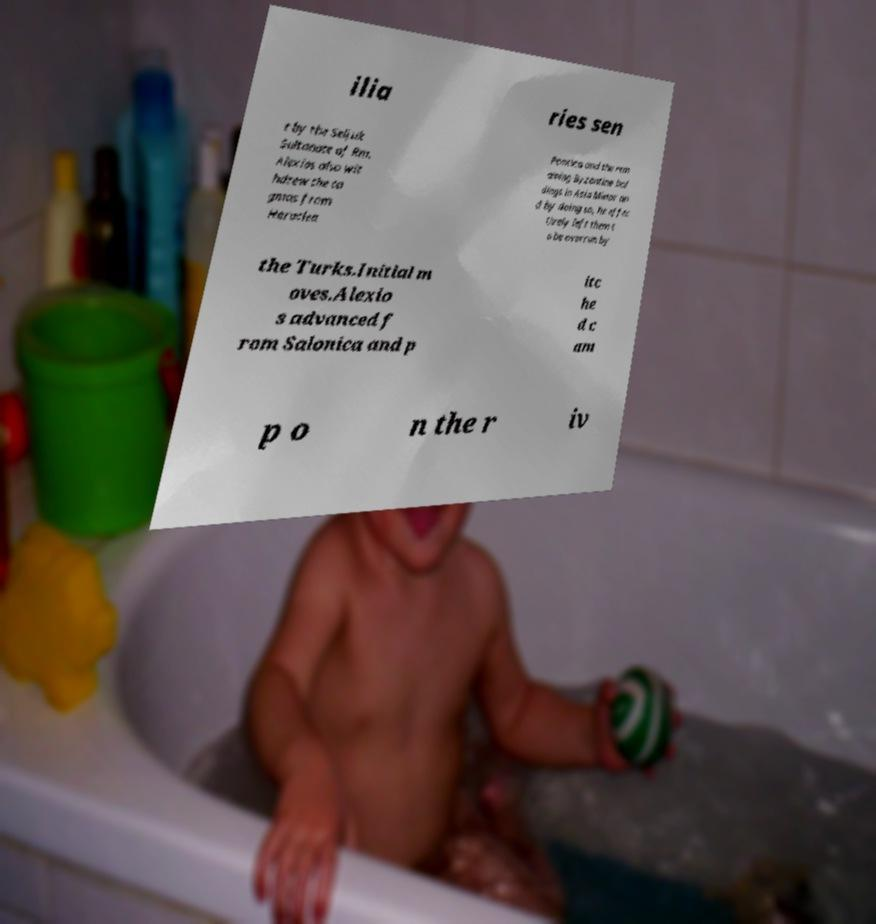There's text embedded in this image that I need extracted. Can you transcribe it verbatim? ilia ries sen t by the Seljuk Sultanate of Rm. Alexios also wit hdrew the ta gmas from Heraclea Pontica and the rem aining Byzantine hol dings in Asia Minor an d by doing so, he effec tively left them t o be overrun by the Turks.Initial m oves.Alexio s advanced f rom Salonica and p itc he d c am p o n the r iv 